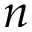<formula> <loc_0><loc_0><loc_500><loc_500>n</formula> 